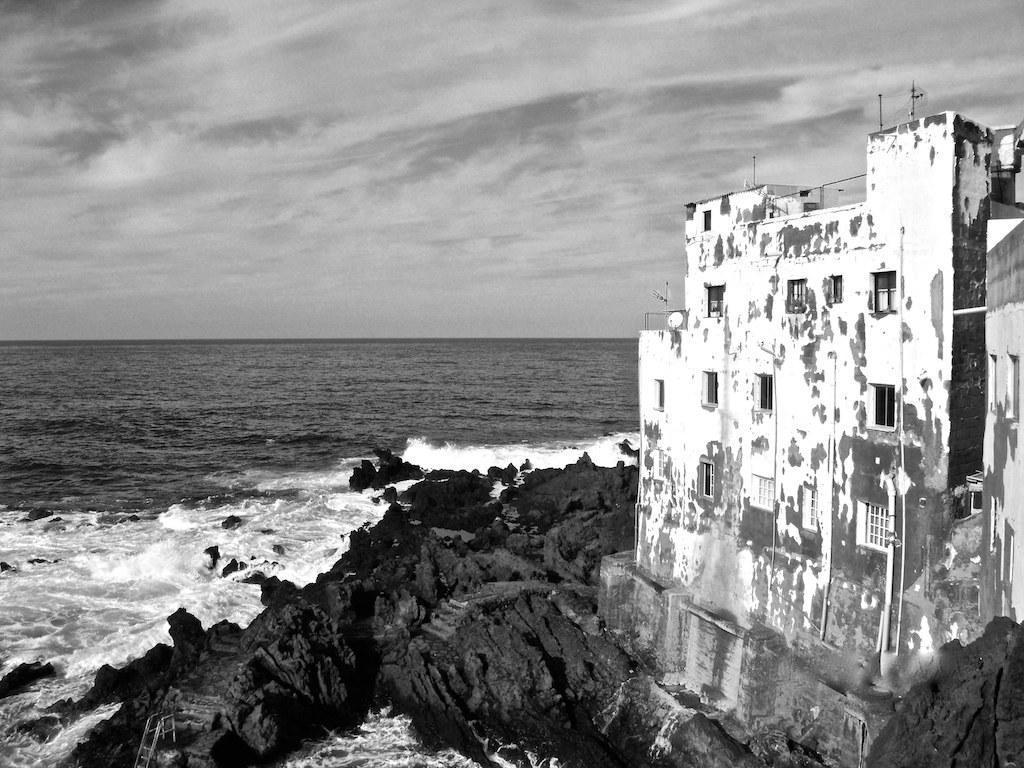In one or two sentences, can you explain what this image depicts? It is a black and white picture. In this picture we can see water, building, rocks, cloudy sky and things. 